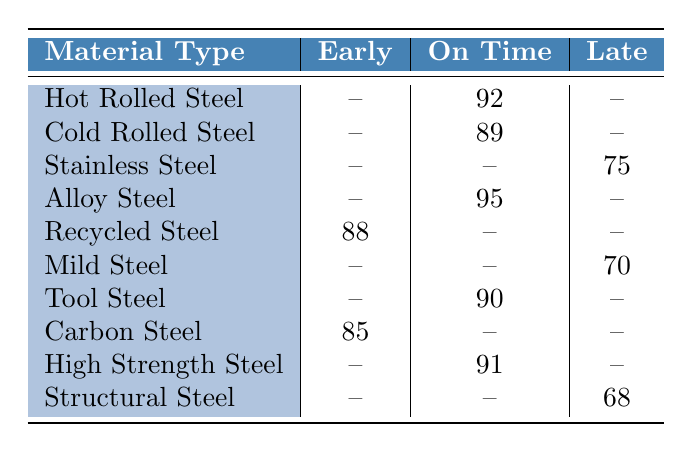What is the reliability score for Recycled Steel? Recycled Steel has a reliability score listed in the table, which is 88 for the delivery timeframe of Early.
Answer: 88 Which material type has the highest reliability score? By examining the table, Alloy Steel has the highest reliability score of 95 listed under the On Time delivery timeframe.
Answer: Alloy Steel How many materials have a reliability score for Late deliveries? There are three materials listed with reliability scores for Late deliveries: Stainless Steel (75), Mild Steel (70), and Structural Steel (68), totaling 3 materials.
Answer: 3 What is the average reliability score for materials delivered on time? The reliability scores for materials delivered On Time are 92 (Hot Rolled Steel), 89 (Cold Rolled Steel), 95 (Alloy Steel), 90 (Tool Steel), and 91 (High Strength Steel). Summing these scores gives 92 + 89 + 95 + 90 + 91 = 457. Dividing by the number of materials (5) gives an average score of 91.4.
Answer: 91.4 Is Steel Dynamics the only supplier with a reliability score for Tool Steel? From the table, Steel Dynamics is indeed the only supplier listed for Tool Steel, as there are no other entries for this material type.
Answer: Yes What is the difference in reliability scores between the highest and lowest scores for Late deliveries? The highest score for Late deliveries is for Stainless Steel (75) and the lowest score is for Structural Steel (68). Thus, the difference is 75 - 68 = 7.
Answer: 7 Do any materials have a reliability score under 75? By reviewing the scores in the Late delivery row, only Structural Steel has a score under 75 (it is 68). Therefore, the answer is yes.
Answer: Yes What are the reliability scores for suppliers that deliver in Early timeframe? The reliability scores for Early deliveries are as follows: Recycled Steel has 88 and Carbon Steel has 85.
Answer: 88, 85 Which material type has a reliability score of 70? The material type with a reliability score of 70 is Mild Steel, as indicated in the Late delivery section of the table.
Answer: Mild Steel 